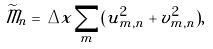Convert formula to latex. <formula><loc_0><loc_0><loc_500><loc_500>\widetilde { \mathcal { M } } _ { n } = \, \Delta x \sum _ { m } ( u _ { m , n } ^ { 2 } + v _ { m , n } ^ { 2 } ) , \\</formula> 